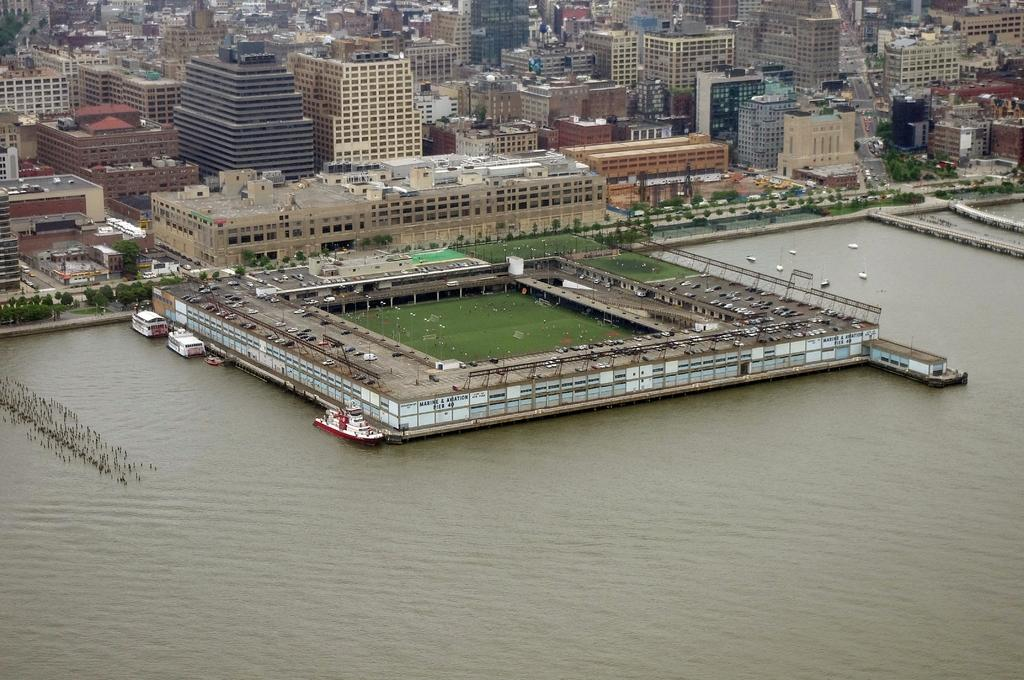What is the primary element in the image? There is water in the image. What is happening on the water? There are boats sailing on the water. What can be seen in the background of the image? There is a stadium, buildings, and trees in the background of the image. What type of poison is being used by the family in the image? There is no family or poison present in the image. What type of spacecraft can be seen in the image? There is no spacecraft present in the image. 